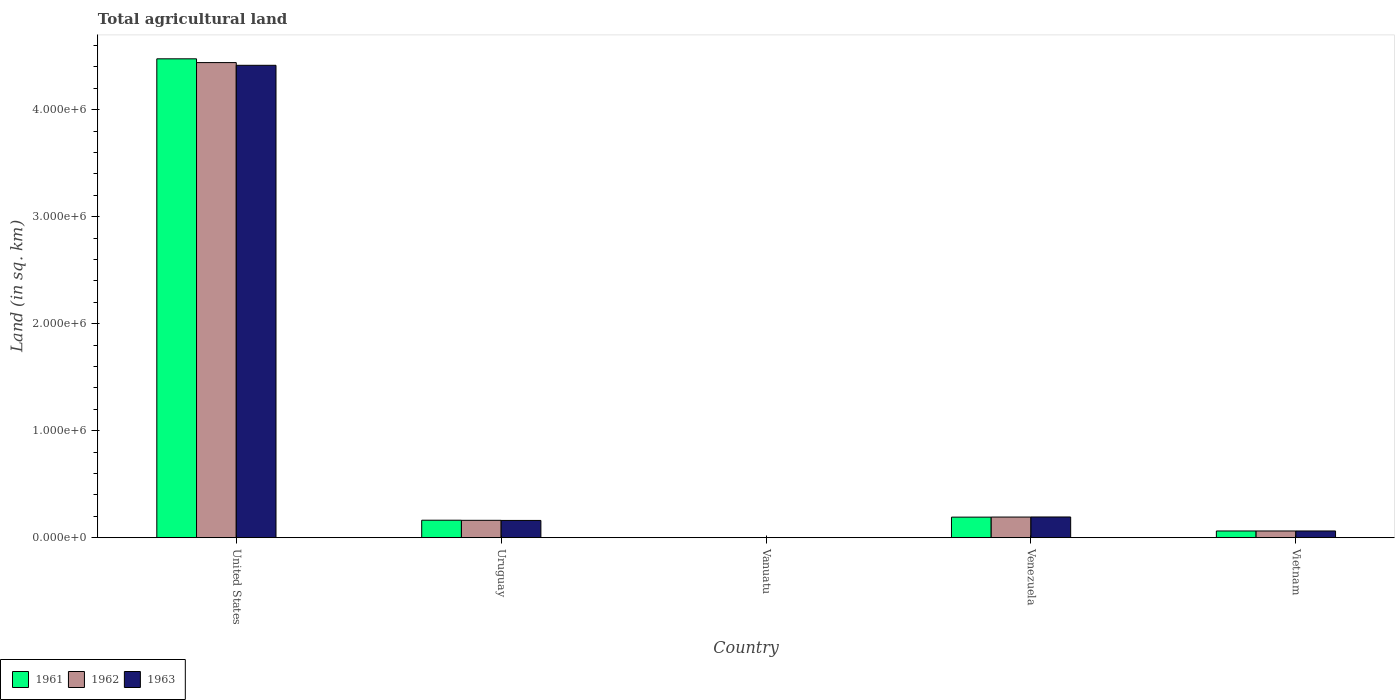How many different coloured bars are there?
Provide a succinct answer. 3. How many groups of bars are there?
Ensure brevity in your answer.  5. How many bars are there on the 5th tick from the right?
Ensure brevity in your answer.  3. What is the label of the 2nd group of bars from the left?
Keep it short and to the point. Uruguay. In how many cases, is the number of bars for a given country not equal to the number of legend labels?
Ensure brevity in your answer.  0. What is the total agricultural land in 1961 in Uruguay?
Keep it short and to the point. 1.64e+05. Across all countries, what is the maximum total agricultural land in 1962?
Keep it short and to the point. 4.44e+06. Across all countries, what is the minimum total agricultural land in 1963?
Offer a very short reply. 1050. In which country was the total agricultural land in 1962 maximum?
Offer a very short reply. United States. In which country was the total agricultural land in 1961 minimum?
Ensure brevity in your answer.  Vanuatu. What is the total total agricultural land in 1963 in the graph?
Make the answer very short. 4.83e+06. What is the difference between the total agricultural land in 1963 in Uruguay and that in Vietnam?
Your answer should be very brief. 9.84e+04. What is the difference between the total agricultural land in 1963 in Venezuela and the total agricultural land in 1961 in Vanuatu?
Provide a short and direct response. 1.93e+05. What is the average total agricultural land in 1962 per country?
Provide a short and direct response. 9.72e+05. What is the difference between the total agricultural land of/in 1963 and total agricultural land of/in 1961 in Uruguay?
Offer a terse response. -2130. What is the ratio of the total agricultural land in 1961 in United States to that in Vietnam?
Give a very brief answer. 71.12. Is the total agricultural land in 1962 in United States less than that in Uruguay?
Offer a terse response. No. What is the difference between the highest and the second highest total agricultural land in 1962?
Make the answer very short. -3.05e+04. What is the difference between the highest and the lowest total agricultural land in 1962?
Your answer should be very brief. 4.44e+06. What does the 3rd bar from the left in United States represents?
Keep it short and to the point. 1963. What does the 1st bar from the right in Venezuela represents?
Provide a short and direct response. 1963. How many bars are there?
Your answer should be compact. 15. Are all the bars in the graph horizontal?
Provide a succinct answer. No. How many countries are there in the graph?
Provide a short and direct response. 5. What is the difference between two consecutive major ticks on the Y-axis?
Keep it short and to the point. 1.00e+06. Are the values on the major ticks of Y-axis written in scientific E-notation?
Your answer should be very brief. Yes. Does the graph contain grids?
Make the answer very short. No. How many legend labels are there?
Your answer should be compact. 3. How are the legend labels stacked?
Your answer should be very brief. Horizontal. What is the title of the graph?
Offer a terse response. Total agricultural land. Does "1962" appear as one of the legend labels in the graph?
Keep it short and to the point. Yes. What is the label or title of the X-axis?
Your answer should be compact. Country. What is the label or title of the Y-axis?
Give a very brief answer. Land (in sq. km). What is the Land (in sq. km) in 1961 in United States?
Your answer should be compact. 4.48e+06. What is the Land (in sq. km) of 1962 in United States?
Your answer should be compact. 4.44e+06. What is the Land (in sq. km) of 1963 in United States?
Offer a very short reply. 4.41e+06. What is the Land (in sq. km) of 1961 in Uruguay?
Provide a succinct answer. 1.64e+05. What is the Land (in sq. km) of 1962 in Uruguay?
Your response must be concise. 1.62e+05. What is the Land (in sq. km) in 1963 in Uruguay?
Provide a succinct answer. 1.61e+05. What is the Land (in sq. km) in 1961 in Vanuatu?
Your response must be concise. 1050. What is the Land (in sq. km) of 1962 in Vanuatu?
Provide a succinct answer. 1050. What is the Land (in sq. km) of 1963 in Vanuatu?
Provide a short and direct response. 1050. What is the Land (in sq. km) of 1961 in Venezuela?
Your answer should be very brief. 1.92e+05. What is the Land (in sq. km) of 1962 in Venezuela?
Your answer should be very brief. 1.93e+05. What is the Land (in sq. km) of 1963 in Venezuela?
Your answer should be compact. 1.94e+05. What is the Land (in sq. km) of 1961 in Vietnam?
Provide a short and direct response. 6.29e+04. What is the Land (in sq. km) of 1962 in Vietnam?
Offer a terse response. 6.30e+04. What is the Land (in sq. km) of 1963 in Vietnam?
Your response must be concise. 6.30e+04. Across all countries, what is the maximum Land (in sq. km) of 1961?
Provide a succinct answer. 4.48e+06. Across all countries, what is the maximum Land (in sq. km) of 1962?
Your answer should be compact. 4.44e+06. Across all countries, what is the maximum Land (in sq. km) in 1963?
Your answer should be compact. 4.41e+06. Across all countries, what is the minimum Land (in sq. km) of 1961?
Keep it short and to the point. 1050. Across all countries, what is the minimum Land (in sq. km) of 1962?
Provide a short and direct response. 1050. Across all countries, what is the minimum Land (in sq. km) of 1963?
Your answer should be very brief. 1050. What is the total Land (in sq. km) in 1961 in the graph?
Offer a terse response. 4.89e+06. What is the total Land (in sq. km) in 1962 in the graph?
Keep it short and to the point. 4.86e+06. What is the total Land (in sq. km) in 1963 in the graph?
Your response must be concise. 4.83e+06. What is the difference between the Land (in sq. km) of 1961 in United States and that in Uruguay?
Offer a terse response. 4.31e+06. What is the difference between the Land (in sq. km) of 1962 in United States and that in Uruguay?
Your answer should be compact. 4.28e+06. What is the difference between the Land (in sq. km) of 1963 in United States and that in Uruguay?
Your response must be concise. 4.25e+06. What is the difference between the Land (in sq. km) in 1961 in United States and that in Vanuatu?
Provide a succinct answer. 4.47e+06. What is the difference between the Land (in sq. km) of 1962 in United States and that in Vanuatu?
Offer a terse response. 4.44e+06. What is the difference between the Land (in sq. km) of 1963 in United States and that in Vanuatu?
Give a very brief answer. 4.41e+06. What is the difference between the Land (in sq. km) of 1961 in United States and that in Venezuela?
Offer a very short reply. 4.28e+06. What is the difference between the Land (in sq. km) of 1962 in United States and that in Venezuela?
Offer a terse response. 4.25e+06. What is the difference between the Land (in sq. km) in 1963 in United States and that in Venezuela?
Provide a short and direct response. 4.22e+06. What is the difference between the Land (in sq. km) in 1961 in United States and that in Vietnam?
Provide a succinct answer. 4.41e+06. What is the difference between the Land (in sq. km) of 1962 in United States and that in Vietnam?
Keep it short and to the point. 4.38e+06. What is the difference between the Land (in sq. km) of 1963 in United States and that in Vietnam?
Make the answer very short. 4.35e+06. What is the difference between the Land (in sq. km) of 1961 in Uruguay and that in Vanuatu?
Your answer should be very brief. 1.62e+05. What is the difference between the Land (in sq. km) of 1962 in Uruguay and that in Vanuatu?
Your answer should be compact. 1.61e+05. What is the difference between the Land (in sq. km) in 1963 in Uruguay and that in Vanuatu?
Your answer should be very brief. 1.60e+05. What is the difference between the Land (in sq. km) in 1961 in Uruguay and that in Venezuela?
Your answer should be very brief. -2.88e+04. What is the difference between the Land (in sq. km) in 1962 in Uruguay and that in Venezuela?
Your response must be concise. -3.05e+04. What is the difference between the Land (in sq. km) in 1963 in Uruguay and that in Venezuela?
Your answer should be very brief. -3.23e+04. What is the difference between the Land (in sq. km) in 1961 in Uruguay and that in Vietnam?
Ensure brevity in your answer.  1.01e+05. What is the difference between the Land (in sq. km) of 1962 in Uruguay and that in Vietnam?
Keep it short and to the point. 9.95e+04. What is the difference between the Land (in sq. km) in 1963 in Uruguay and that in Vietnam?
Ensure brevity in your answer.  9.84e+04. What is the difference between the Land (in sq. km) of 1961 in Vanuatu and that in Venezuela?
Your response must be concise. -1.91e+05. What is the difference between the Land (in sq. km) of 1962 in Vanuatu and that in Venezuela?
Keep it short and to the point. -1.92e+05. What is the difference between the Land (in sq. km) of 1963 in Vanuatu and that in Venezuela?
Make the answer very short. -1.93e+05. What is the difference between the Land (in sq. km) in 1961 in Vanuatu and that in Vietnam?
Offer a very short reply. -6.19e+04. What is the difference between the Land (in sq. km) in 1962 in Vanuatu and that in Vietnam?
Your response must be concise. -6.19e+04. What is the difference between the Land (in sq. km) of 1963 in Vanuatu and that in Vietnam?
Your response must be concise. -6.20e+04. What is the difference between the Land (in sq. km) of 1961 in Venezuela and that in Vietnam?
Ensure brevity in your answer.  1.29e+05. What is the difference between the Land (in sq. km) in 1962 in Venezuela and that in Vietnam?
Give a very brief answer. 1.30e+05. What is the difference between the Land (in sq. km) in 1963 in Venezuela and that in Vietnam?
Ensure brevity in your answer.  1.31e+05. What is the difference between the Land (in sq. km) in 1961 in United States and the Land (in sq. km) in 1962 in Uruguay?
Make the answer very short. 4.31e+06. What is the difference between the Land (in sq. km) of 1961 in United States and the Land (in sq. km) of 1963 in Uruguay?
Offer a terse response. 4.31e+06. What is the difference between the Land (in sq. km) of 1962 in United States and the Land (in sq. km) of 1963 in Uruguay?
Offer a terse response. 4.28e+06. What is the difference between the Land (in sq. km) of 1961 in United States and the Land (in sq. km) of 1962 in Vanuatu?
Ensure brevity in your answer.  4.47e+06. What is the difference between the Land (in sq. km) of 1961 in United States and the Land (in sq. km) of 1963 in Vanuatu?
Your answer should be compact. 4.47e+06. What is the difference between the Land (in sq. km) of 1962 in United States and the Land (in sq. km) of 1963 in Vanuatu?
Make the answer very short. 4.44e+06. What is the difference between the Land (in sq. km) of 1961 in United States and the Land (in sq. km) of 1962 in Venezuela?
Keep it short and to the point. 4.28e+06. What is the difference between the Land (in sq. km) of 1961 in United States and the Land (in sq. km) of 1963 in Venezuela?
Keep it short and to the point. 4.28e+06. What is the difference between the Land (in sq. km) of 1962 in United States and the Land (in sq. km) of 1963 in Venezuela?
Your answer should be compact. 4.25e+06. What is the difference between the Land (in sq. km) of 1961 in United States and the Land (in sq. km) of 1962 in Vietnam?
Your answer should be compact. 4.41e+06. What is the difference between the Land (in sq. km) of 1961 in United States and the Land (in sq. km) of 1963 in Vietnam?
Make the answer very short. 4.41e+06. What is the difference between the Land (in sq. km) in 1962 in United States and the Land (in sq. km) in 1963 in Vietnam?
Ensure brevity in your answer.  4.38e+06. What is the difference between the Land (in sq. km) in 1961 in Uruguay and the Land (in sq. km) in 1962 in Vanuatu?
Offer a terse response. 1.62e+05. What is the difference between the Land (in sq. km) of 1961 in Uruguay and the Land (in sq. km) of 1963 in Vanuatu?
Keep it short and to the point. 1.62e+05. What is the difference between the Land (in sq. km) in 1962 in Uruguay and the Land (in sq. km) in 1963 in Vanuatu?
Your response must be concise. 1.61e+05. What is the difference between the Land (in sq. km) of 1961 in Uruguay and the Land (in sq. km) of 1962 in Venezuela?
Offer a terse response. -2.95e+04. What is the difference between the Land (in sq. km) of 1961 in Uruguay and the Land (in sq. km) of 1963 in Venezuela?
Your response must be concise. -3.02e+04. What is the difference between the Land (in sq. km) of 1962 in Uruguay and the Land (in sq. km) of 1963 in Venezuela?
Ensure brevity in your answer.  -3.12e+04. What is the difference between the Land (in sq. km) in 1961 in Uruguay and the Land (in sq. km) in 1962 in Vietnam?
Your answer should be compact. 1.01e+05. What is the difference between the Land (in sq. km) in 1961 in Uruguay and the Land (in sq. km) in 1963 in Vietnam?
Make the answer very short. 1.01e+05. What is the difference between the Land (in sq. km) in 1962 in Uruguay and the Land (in sq. km) in 1963 in Vietnam?
Offer a terse response. 9.95e+04. What is the difference between the Land (in sq. km) in 1961 in Vanuatu and the Land (in sq. km) in 1962 in Venezuela?
Offer a terse response. -1.92e+05. What is the difference between the Land (in sq. km) of 1961 in Vanuatu and the Land (in sq. km) of 1963 in Venezuela?
Make the answer very short. -1.93e+05. What is the difference between the Land (in sq. km) in 1962 in Vanuatu and the Land (in sq. km) in 1963 in Venezuela?
Provide a short and direct response. -1.93e+05. What is the difference between the Land (in sq. km) in 1961 in Vanuatu and the Land (in sq. km) in 1962 in Vietnam?
Provide a short and direct response. -6.19e+04. What is the difference between the Land (in sq. km) of 1961 in Vanuatu and the Land (in sq. km) of 1963 in Vietnam?
Ensure brevity in your answer.  -6.20e+04. What is the difference between the Land (in sq. km) of 1962 in Vanuatu and the Land (in sq. km) of 1963 in Vietnam?
Make the answer very short. -6.20e+04. What is the difference between the Land (in sq. km) of 1961 in Venezuela and the Land (in sq. km) of 1962 in Vietnam?
Give a very brief answer. 1.29e+05. What is the difference between the Land (in sq. km) in 1961 in Venezuela and the Land (in sq. km) in 1963 in Vietnam?
Offer a terse response. 1.29e+05. What is the average Land (in sq. km) of 1961 per country?
Give a very brief answer. 9.79e+05. What is the average Land (in sq. km) of 1962 per country?
Provide a short and direct response. 9.72e+05. What is the average Land (in sq. km) in 1963 per country?
Provide a succinct answer. 9.67e+05. What is the difference between the Land (in sq. km) of 1961 and Land (in sq. km) of 1962 in United States?
Make the answer very short. 3.52e+04. What is the difference between the Land (in sq. km) of 1961 and Land (in sq. km) of 1963 in United States?
Offer a very short reply. 6.07e+04. What is the difference between the Land (in sq. km) in 1962 and Land (in sq. km) in 1963 in United States?
Your answer should be compact. 2.55e+04. What is the difference between the Land (in sq. km) in 1961 and Land (in sq. km) in 1962 in Uruguay?
Your answer should be compact. 1050. What is the difference between the Land (in sq. km) in 1961 and Land (in sq. km) in 1963 in Uruguay?
Offer a terse response. 2130. What is the difference between the Land (in sq. km) of 1962 and Land (in sq. km) of 1963 in Uruguay?
Provide a succinct answer. 1080. What is the difference between the Land (in sq. km) of 1961 and Land (in sq. km) of 1963 in Vanuatu?
Give a very brief answer. 0. What is the difference between the Land (in sq. km) in 1961 and Land (in sq. km) in 1962 in Venezuela?
Ensure brevity in your answer.  -700. What is the difference between the Land (in sq. km) of 1961 and Land (in sq. km) of 1963 in Venezuela?
Offer a terse response. -1400. What is the difference between the Land (in sq. km) in 1962 and Land (in sq. km) in 1963 in Venezuela?
Offer a terse response. -700. What is the difference between the Land (in sq. km) in 1961 and Land (in sq. km) in 1962 in Vietnam?
Ensure brevity in your answer.  -50. What is the difference between the Land (in sq. km) of 1961 and Land (in sq. km) of 1963 in Vietnam?
Make the answer very short. -100. What is the ratio of the Land (in sq. km) of 1961 in United States to that in Uruguay?
Give a very brief answer. 27.36. What is the ratio of the Land (in sq. km) in 1962 in United States to that in Uruguay?
Your answer should be compact. 27.32. What is the ratio of the Land (in sq. km) in 1963 in United States to that in Uruguay?
Ensure brevity in your answer.  27.35. What is the ratio of the Land (in sq. km) in 1961 in United States to that in Vanuatu?
Give a very brief answer. 4261.99. What is the ratio of the Land (in sq. km) of 1962 in United States to that in Vanuatu?
Make the answer very short. 4228.49. What is the ratio of the Land (in sq. km) of 1963 in United States to that in Vanuatu?
Your answer should be compact. 4204.22. What is the ratio of the Land (in sq. km) of 1961 in United States to that in Venezuela?
Make the answer very short. 23.27. What is the ratio of the Land (in sq. km) of 1962 in United States to that in Venezuela?
Give a very brief answer. 23. What is the ratio of the Land (in sq. km) in 1963 in United States to that in Venezuela?
Your answer should be very brief. 22.79. What is the ratio of the Land (in sq. km) in 1961 in United States to that in Vietnam?
Offer a very short reply. 71.12. What is the ratio of the Land (in sq. km) in 1962 in United States to that in Vietnam?
Your response must be concise. 70.51. What is the ratio of the Land (in sq. km) in 1963 in United States to that in Vietnam?
Make the answer very short. 70.05. What is the ratio of the Land (in sq. km) of 1961 in Uruguay to that in Vanuatu?
Ensure brevity in your answer.  155.75. What is the ratio of the Land (in sq. km) in 1962 in Uruguay to that in Vanuatu?
Offer a very short reply. 154.75. What is the ratio of the Land (in sq. km) of 1963 in Uruguay to that in Vanuatu?
Provide a succinct answer. 153.72. What is the ratio of the Land (in sq. km) in 1961 in Uruguay to that in Venezuela?
Make the answer very short. 0.85. What is the ratio of the Land (in sq. km) in 1962 in Uruguay to that in Venezuela?
Make the answer very short. 0.84. What is the ratio of the Land (in sq. km) of 1963 in Uruguay to that in Venezuela?
Give a very brief answer. 0.83. What is the ratio of the Land (in sq. km) of 1961 in Uruguay to that in Vietnam?
Offer a terse response. 2.6. What is the ratio of the Land (in sq. km) of 1962 in Uruguay to that in Vietnam?
Your answer should be very brief. 2.58. What is the ratio of the Land (in sq. km) of 1963 in Uruguay to that in Vietnam?
Offer a terse response. 2.56. What is the ratio of the Land (in sq. km) in 1961 in Vanuatu to that in Venezuela?
Offer a terse response. 0.01. What is the ratio of the Land (in sq. km) in 1962 in Vanuatu to that in Venezuela?
Offer a very short reply. 0.01. What is the ratio of the Land (in sq. km) of 1963 in Vanuatu to that in Venezuela?
Your answer should be very brief. 0.01. What is the ratio of the Land (in sq. km) of 1961 in Vanuatu to that in Vietnam?
Keep it short and to the point. 0.02. What is the ratio of the Land (in sq. km) in 1962 in Vanuatu to that in Vietnam?
Ensure brevity in your answer.  0.02. What is the ratio of the Land (in sq. km) of 1963 in Vanuatu to that in Vietnam?
Keep it short and to the point. 0.02. What is the ratio of the Land (in sq. km) of 1961 in Venezuela to that in Vietnam?
Keep it short and to the point. 3.06. What is the ratio of the Land (in sq. km) in 1962 in Venezuela to that in Vietnam?
Make the answer very short. 3.07. What is the ratio of the Land (in sq. km) in 1963 in Venezuela to that in Vietnam?
Provide a short and direct response. 3.07. What is the difference between the highest and the second highest Land (in sq. km) in 1961?
Your response must be concise. 4.28e+06. What is the difference between the highest and the second highest Land (in sq. km) of 1962?
Provide a short and direct response. 4.25e+06. What is the difference between the highest and the second highest Land (in sq. km) in 1963?
Ensure brevity in your answer.  4.22e+06. What is the difference between the highest and the lowest Land (in sq. km) of 1961?
Offer a very short reply. 4.47e+06. What is the difference between the highest and the lowest Land (in sq. km) of 1962?
Your answer should be very brief. 4.44e+06. What is the difference between the highest and the lowest Land (in sq. km) in 1963?
Provide a short and direct response. 4.41e+06. 